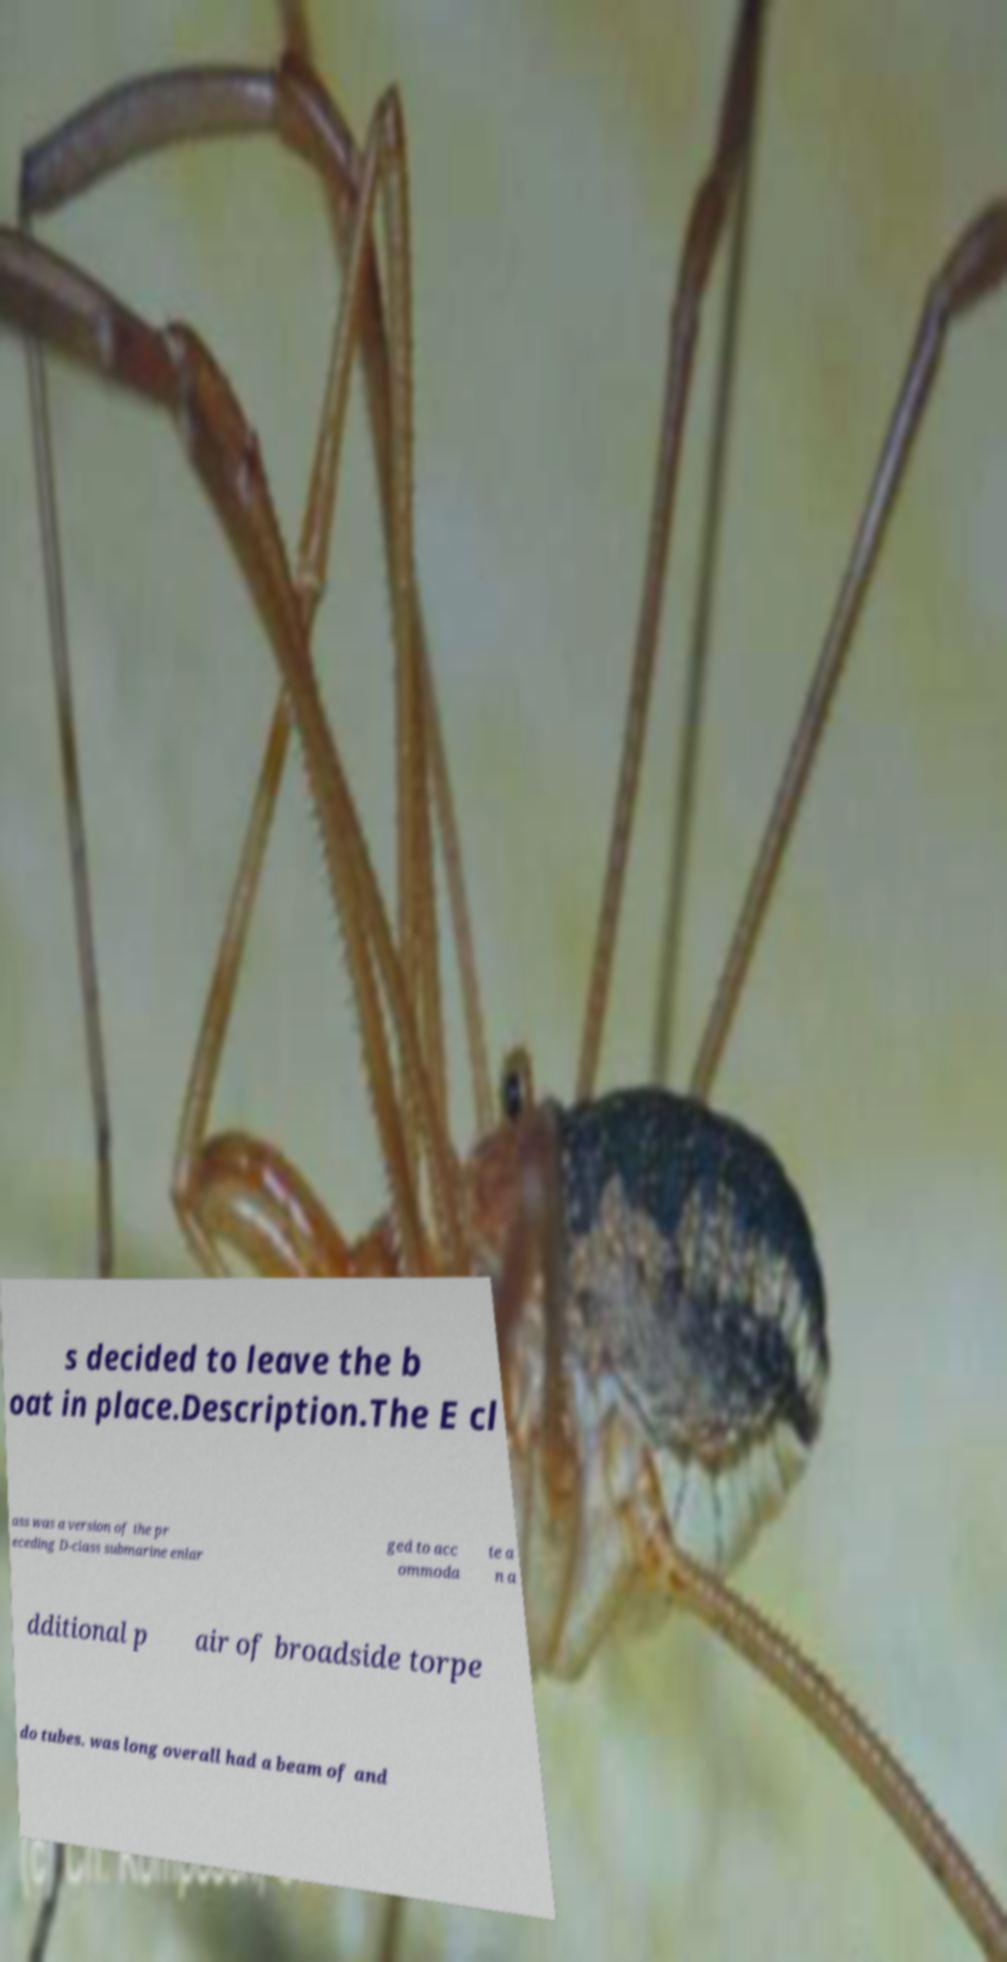Please read and relay the text visible in this image. What does it say? s decided to leave the b oat in place.Description.The E cl ass was a version of the pr eceding D-class submarine enlar ged to acc ommoda te a n a dditional p air of broadside torpe do tubes. was long overall had a beam of and 